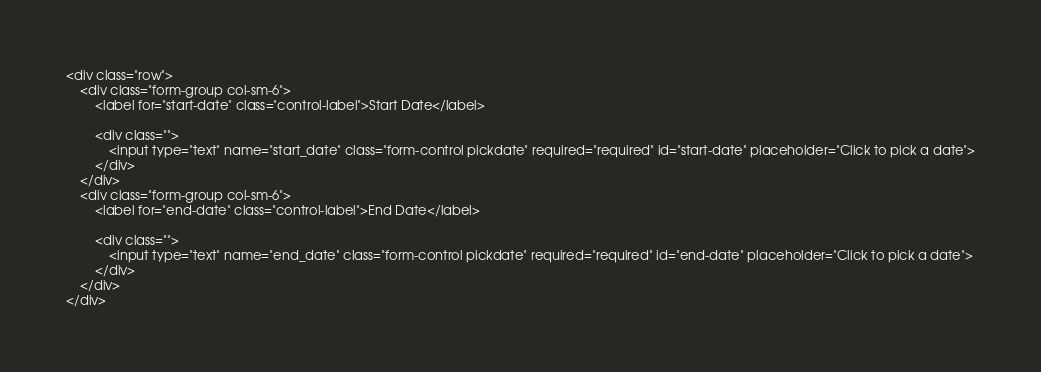Convert code to text. <code><loc_0><loc_0><loc_500><loc_500><_PHP_><div class="row">
    <div class="form-group col-sm-6">
        <label for="start-date" class="control-label">Start Date</label>

        <div class="">
            <input type="text" name="start_date" class="form-control pickdate" required="required" id="start-date" placeholder="Click to pick a date">
        </div>
    </div>
    <div class="form-group col-sm-6">
        <label for="end-date" class="control-label">End Date</label>

        <div class="">
            <input type="text" name="end_date" class="form-control pickdate" required="required" id="end-date" placeholder="Click to pick a date">
        </div>
    </div>
</div></code> 